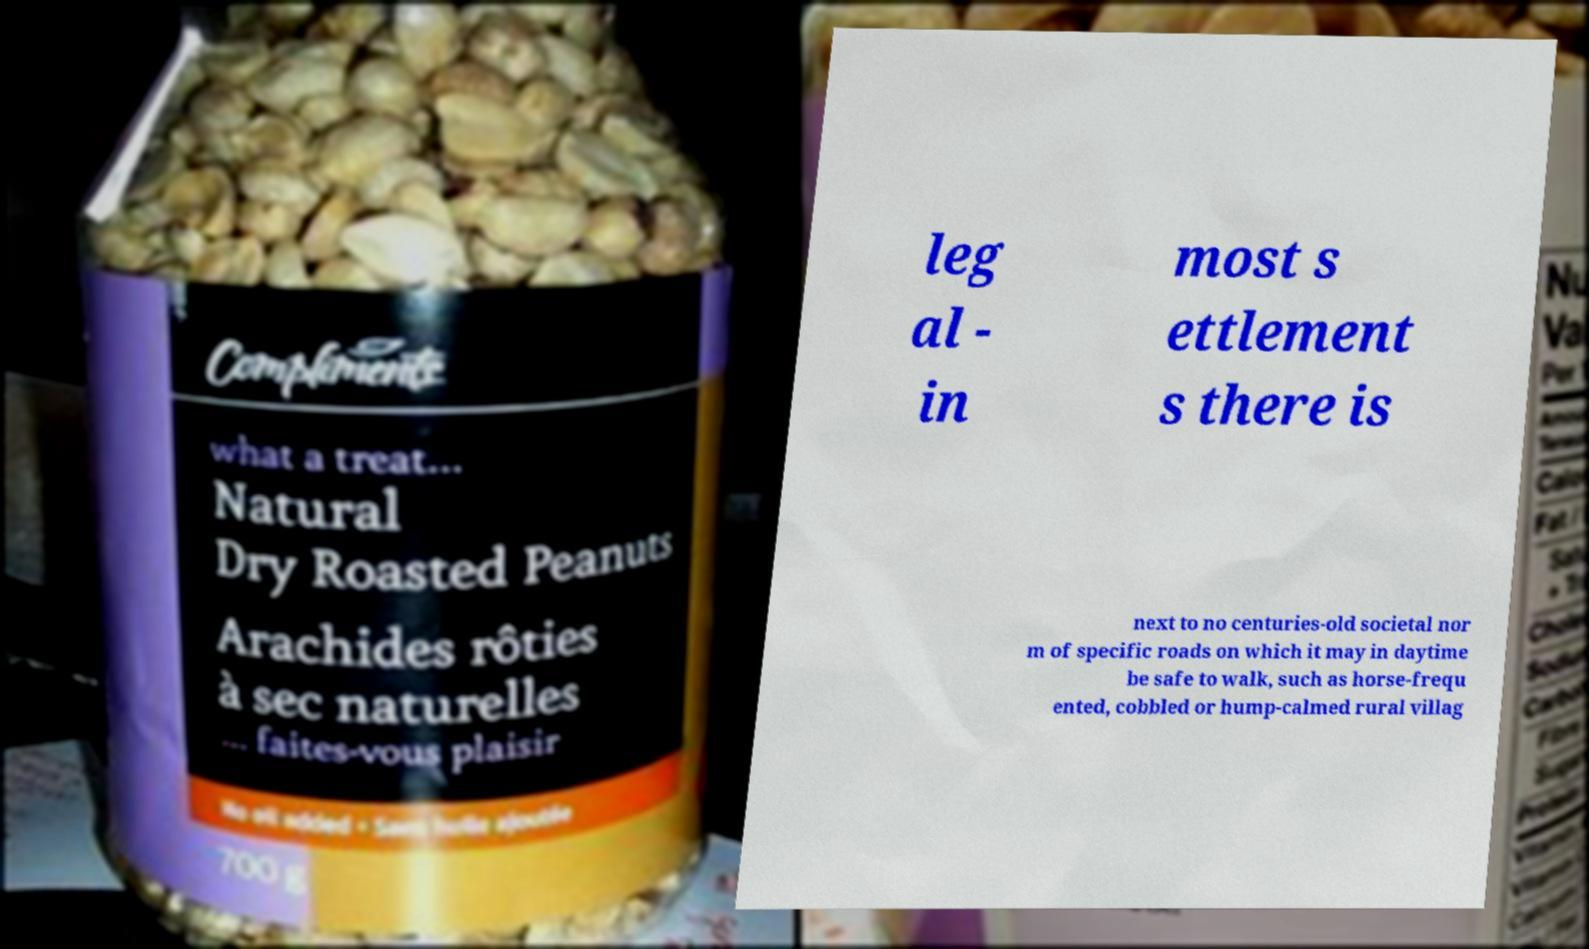Please identify and transcribe the text found in this image. leg al - in most s ettlement s there is next to no centuries-old societal nor m of specific roads on which it may in daytime be safe to walk, such as horse-frequ ented, cobbled or hump-calmed rural villag 